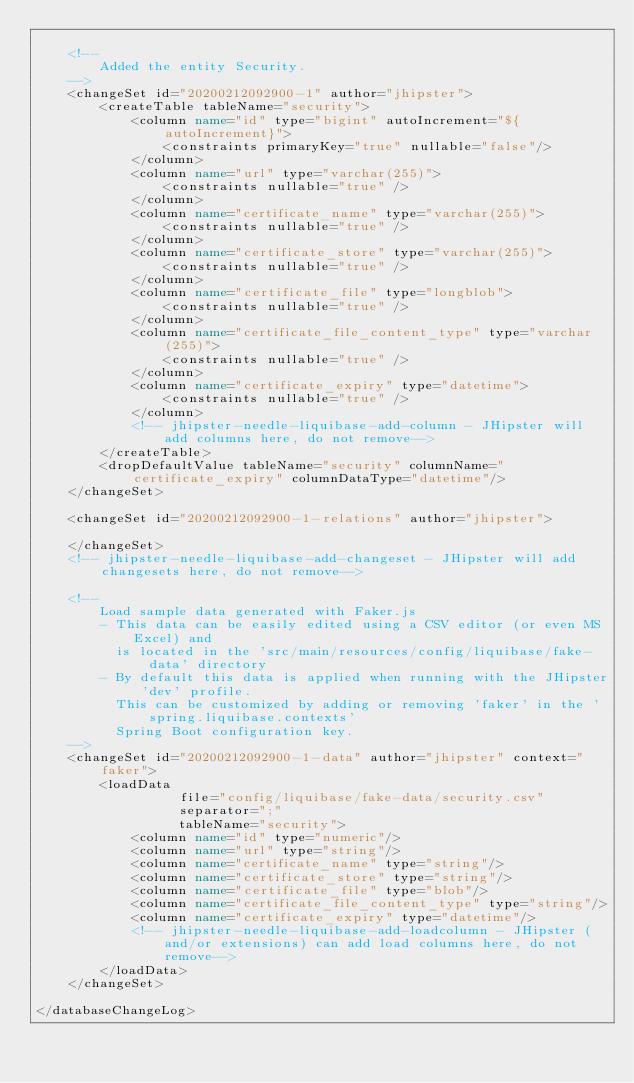<code> <loc_0><loc_0><loc_500><loc_500><_XML_>
    <!--
        Added the entity Security.
    -->
    <changeSet id="20200212092900-1" author="jhipster">
        <createTable tableName="security">
            <column name="id" type="bigint" autoIncrement="${autoIncrement}">
                <constraints primaryKey="true" nullable="false"/>
            </column>
            <column name="url" type="varchar(255)">
                <constraints nullable="true" />
            </column>
            <column name="certificate_name" type="varchar(255)">
                <constraints nullable="true" />
            </column>
            <column name="certificate_store" type="varchar(255)">
                <constraints nullable="true" />
            </column>
            <column name="certificate_file" type="longblob">
                <constraints nullable="true" />
            </column>
            <column name="certificate_file_content_type" type="varchar(255)">
                <constraints nullable="true" />
            </column>
            <column name="certificate_expiry" type="datetime">
                <constraints nullable="true" />
            </column>
            <!-- jhipster-needle-liquibase-add-column - JHipster will add columns here, do not remove-->
        </createTable>
        <dropDefaultValue tableName="security" columnName="certificate_expiry" columnDataType="datetime"/>
    </changeSet>

    <changeSet id="20200212092900-1-relations" author="jhipster">

    </changeSet>
    <!-- jhipster-needle-liquibase-add-changeset - JHipster will add changesets here, do not remove-->

    <!--
        Load sample data generated with Faker.js
        - This data can be easily edited using a CSV editor (or even MS Excel) and
          is located in the 'src/main/resources/config/liquibase/fake-data' directory
        - By default this data is applied when running with the JHipster 'dev' profile.
          This can be customized by adding or removing 'faker' in the 'spring.liquibase.contexts'
          Spring Boot configuration key.
    -->
    <changeSet id="20200212092900-1-data" author="jhipster" context="faker">
        <loadData
                  file="config/liquibase/fake-data/security.csv"
                  separator=";"
                  tableName="security">
            <column name="id" type="numeric"/>
            <column name="url" type="string"/>
            <column name="certificate_name" type="string"/>
            <column name="certificate_store" type="string"/>
            <column name="certificate_file" type="blob"/>
            <column name="certificate_file_content_type" type="string"/>
            <column name="certificate_expiry" type="datetime"/>
            <!-- jhipster-needle-liquibase-add-loadcolumn - JHipster (and/or extensions) can add load columns here, do not remove-->
        </loadData>
    </changeSet>

</databaseChangeLog>
</code> 